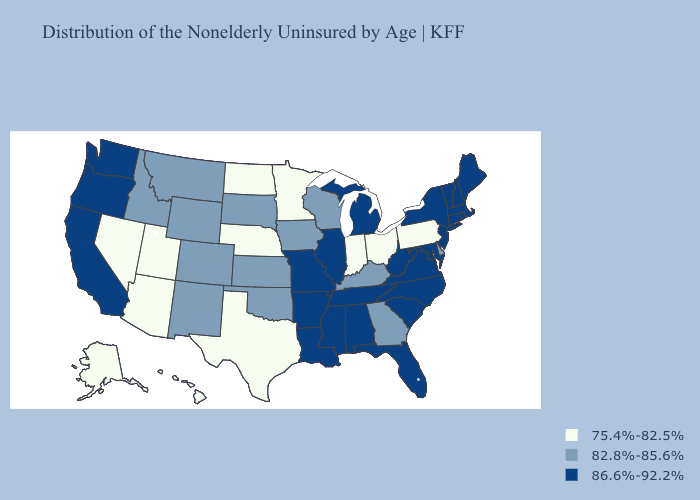Among the states that border Minnesota , does North Dakota have the highest value?
Give a very brief answer. No. What is the lowest value in the USA?
Concise answer only. 75.4%-82.5%. Does North Dakota have the lowest value in the USA?
Answer briefly. Yes. Which states have the lowest value in the MidWest?
Give a very brief answer. Indiana, Minnesota, Nebraska, North Dakota, Ohio. Name the states that have a value in the range 82.8%-85.6%?
Concise answer only. Colorado, Delaware, Georgia, Idaho, Iowa, Kansas, Kentucky, Montana, New Mexico, Oklahoma, South Dakota, Wisconsin, Wyoming. Name the states that have a value in the range 86.6%-92.2%?
Quick response, please. Alabama, Arkansas, California, Connecticut, Florida, Illinois, Louisiana, Maine, Maryland, Massachusetts, Michigan, Mississippi, Missouri, New Hampshire, New Jersey, New York, North Carolina, Oregon, Rhode Island, South Carolina, Tennessee, Vermont, Virginia, Washington, West Virginia. Which states have the lowest value in the West?
Write a very short answer. Alaska, Arizona, Hawaii, Nevada, Utah. Name the states that have a value in the range 86.6%-92.2%?
Concise answer only. Alabama, Arkansas, California, Connecticut, Florida, Illinois, Louisiana, Maine, Maryland, Massachusetts, Michigan, Mississippi, Missouri, New Hampshire, New Jersey, New York, North Carolina, Oregon, Rhode Island, South Carolina, Tennessee, Vermont, Virginia, Washington, West Virginia. Which states have the highest value in the USA?
Quick response, please. Alabama, Arkansas, California, Connecticut, Florida, Illinois, Louisiana, Maine, Maryland, Massachusetts, Michigan, Mississippi, Missouri, New Hampshire, New Jersey, New York, North Carolina, Oregon, Rhode Island, South Carolina, Tennessee, Vermont, Virginia, Washington, West Virginia. What is the highest value in states that border Missouri?
Short answer required. 86.6%-92.2%. What is the highest value in the West ?
Be succinct. 86.6%-92.2%. Among the states that border North Carolina , does Georgia have the highest value?
Answer briefly. No. 